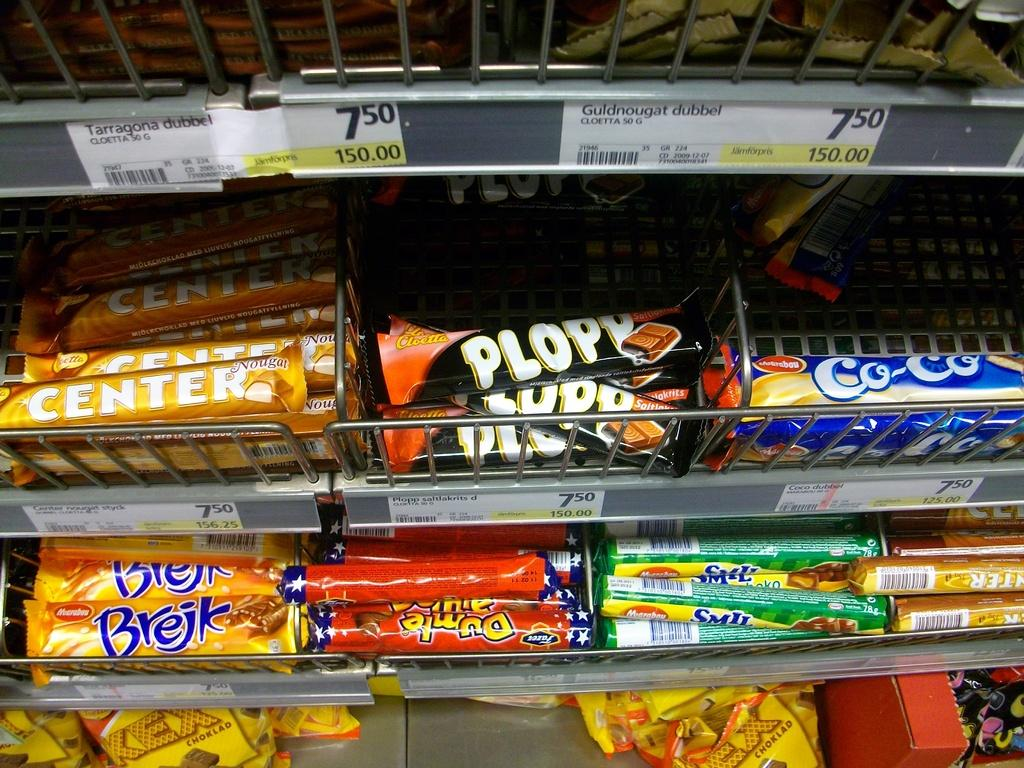Provide a one-sentence caption for the provided image. a display of different candy bars with the top middle called plopp. 